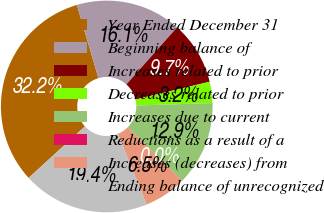<chart> <loc_0><loc_0><loc_500><loc_500><pie_chart><fcel>Year Ended December 31<fcel>Beginning balance of<fcel>Increases related to prior<fcel>Decreases related to prior<fcel>Increases due to current<fcel>Reductions as a result of a<fcel>Increases (decreases) from<fcel>Ending balance of unrecognized<nl><fcel>32.23%<fcel>16.12%<fcel>9.68%<fcel>3.24%<fcel>12.9%<fcel>0.02%<fcel>6.46%<fcel>19.35%<nl></chart> 